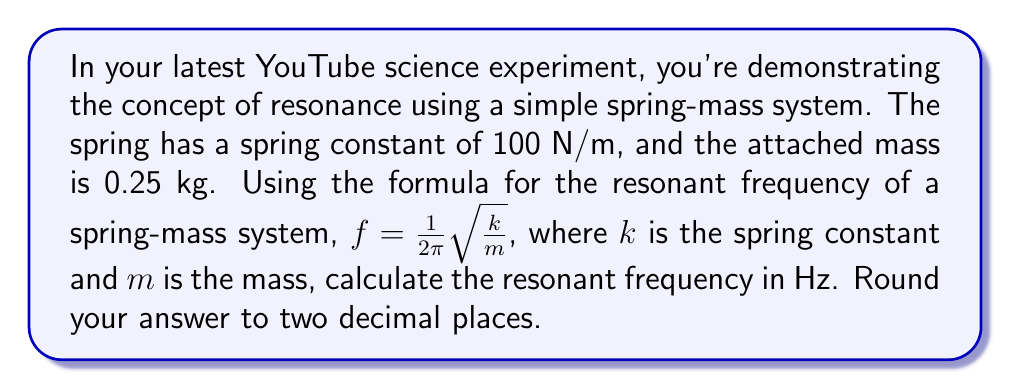Give your solution to this math problem. Let's solve this step-by-step:

1) We are given:
   $k = 100$ N/m (spring constant)
   $m = 0.25$ kg (mass)

2) The formula for resonant frequency is:
   $f = \frac{1}{2\pi}\sqrt{\frac{k}{m}}$

3) Let's substitute our values:
   $f = \frac{1}{2\pi}\sqrt{\frac{100}{0.25}}$

4) Simplify inside the square root:
   $f = \frac{1}{2\pi}\sqrt{400}$

5) Calculate the square root:
   $f = \frac{1}{2\pi} \cdot 20$

6) Simplify:
   $f = \frac{20}{2\pi} = \frac{10}{\pi}$

7) Use a calculator to divide and round to two decimal places:
   $f \approx 3.18$ Hz
Answer: 3.18 Hz 